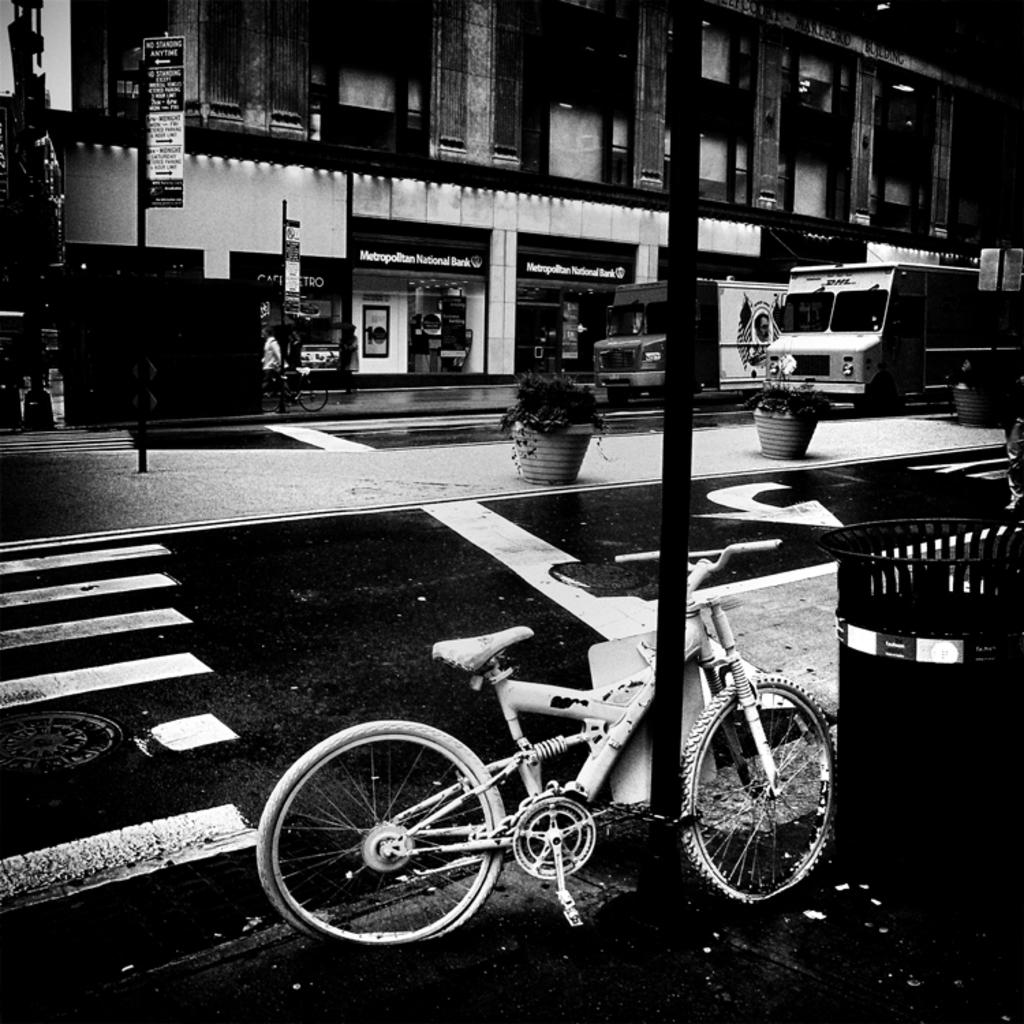What type of vehicle is on the road in the image? The image does not specify the type of vehicle on the road. What can be found near the road in the image? There is a plant pot, a bicycle, a dustbin, a building, a board, a person wearing clothes, and a pole in the image. Can you describe the road in the image? The image shows a road with various objects and structures nearby. What is the person wearing clothes doing in the image? The image does not show any specific action being performed by the person wearing clothes. What type of knowledge does the mouth of the person in the image possess? There is no mouth visible in the image, and therefore no knowledge can be attributed to it. 